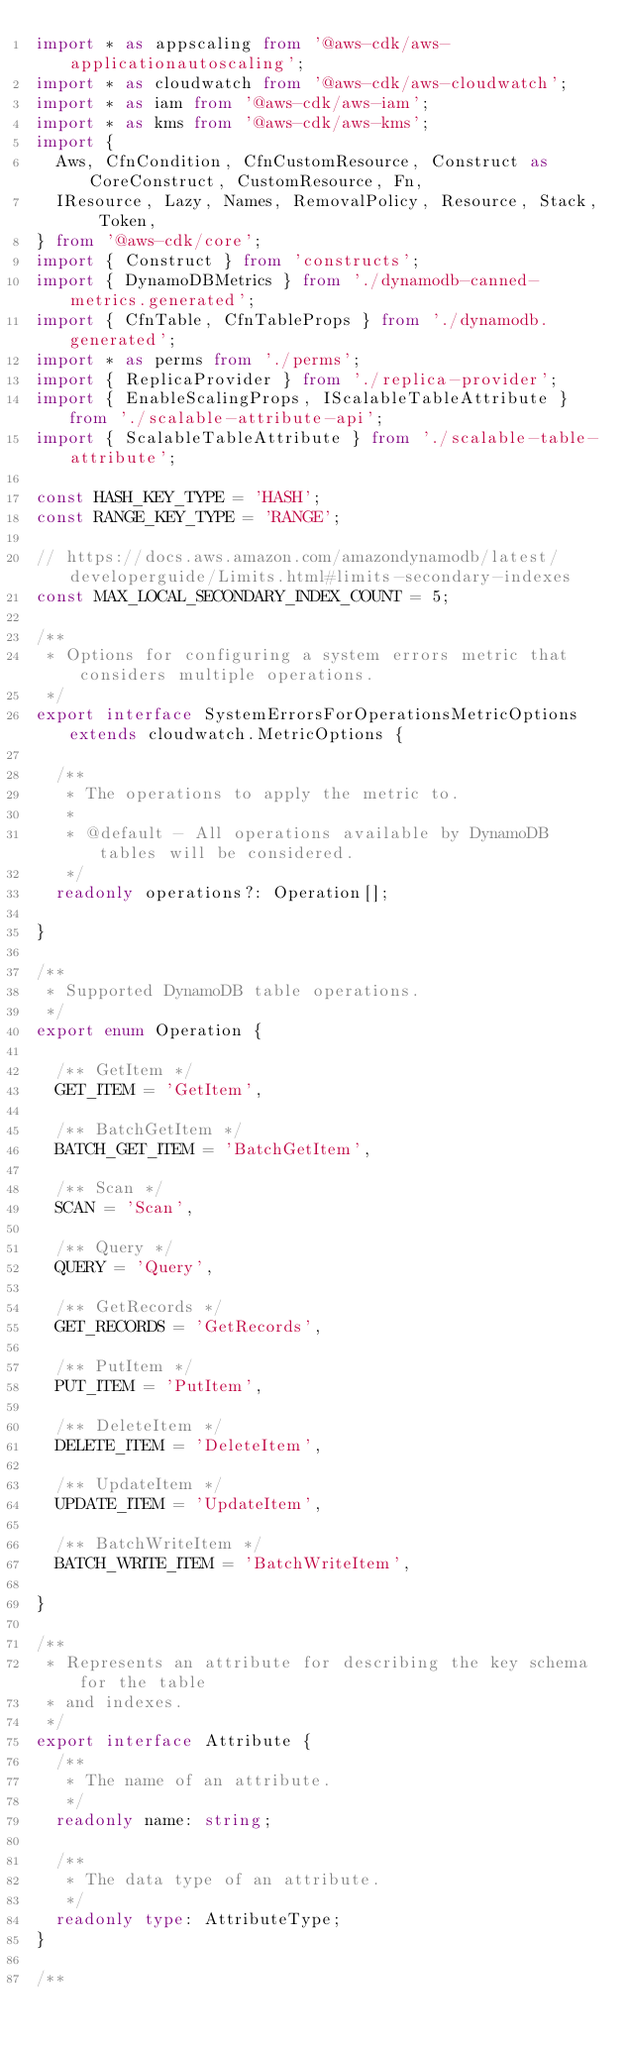<code> <loc_0><loc_0><loc_500><loc_500><_TypeScript_>import * as appscaling from '@aws-cdk/aws-applicationautoscaling';
import * as cloudwatch from '@aws-cdk/aws-cloudwatch';
import * as iam from '@aws-cdk/aws-iam';
import * as kms from '@aws-cdk/aws-kms';
import {
  Aws, CfnCondition, CfnCustomResource, Construct as CoreConstruct, CustomResource, Fn,
  IResource, Lazy, Names, RemovalPolicy, Resource, Stack, Token,
} from '@aws-cdk/core';
import { Construct } from 'constructs';
import { DynamoDBMetrics } from './dynamodb-canned-metrics.generated';
import { CfnTable, CfnTableProps } from './dynamodb.generated';
import * as perms from './perms';
import { ReplicaProvider } from './replica-provider';
import { EnableScalingProps, IScalableTableAttribute } from './scalable-attribute-api';
import { ScalableTableAttribute } from './scalable-table-attribute';

const HASH_KEY_TYPE = 'HASH';
const RANGE_KEY_TYPE = 'RANGE';

// https://docs.aws.amazon.com/amazondynamodb/latest/developerguide/Limits.html#limits-secondary-indexes
const MAX_LOCAL_SECONDARY_INDEX_COUNT = 5;

/**
 * Options for configuring a system errors metric that considers multiple operations.
 */
export interface SystemErrorsForOperationsMetricOptions extends cloudwatch.MetricOptions {

  /**
   * The operations to apply the metric to.
   *
   * @default - All operations available by DynamoDB tables will be considered.
   */
  readonly operations?: Operation[];

}

/**
 * Supported DynamoDB table operations.
 */
export enum Operation {

  /** GetItem */
  GET_ITEM = 'GetItem',

  /** BatchGetItem */
  BATCH_GET_ITEM = 'BatchGetItem',

  /** Scan */
  SCAN = 'Scan',

  /** Query */
  QUERY = 'Query',

  /** GetRecords */
  GET_RECORDS = 'GetRecords',

  /** PutItem */
  PUT_ITEM = 'PutItem',

  /** DeleteItem */
  DELETE_ITEM = 'DeleteItem',

  /** UpdateItem */
  UPDATE_ITEM = 'UpdateItem',

  /** BatchWriteItem */
  BATCH_WRITE_ITEM = 'BatchWriteItem',

}

/**
 * Represents an attribute for describing the key schema for the table
 * and indexes.
 */
export interface Attribute {
  /**
   * The name of an attribute.
   */
  readonly name: string;

  /**
   * The data type of an attribute.
   */
  readonly type: AttributeType;
}

/**</code> 